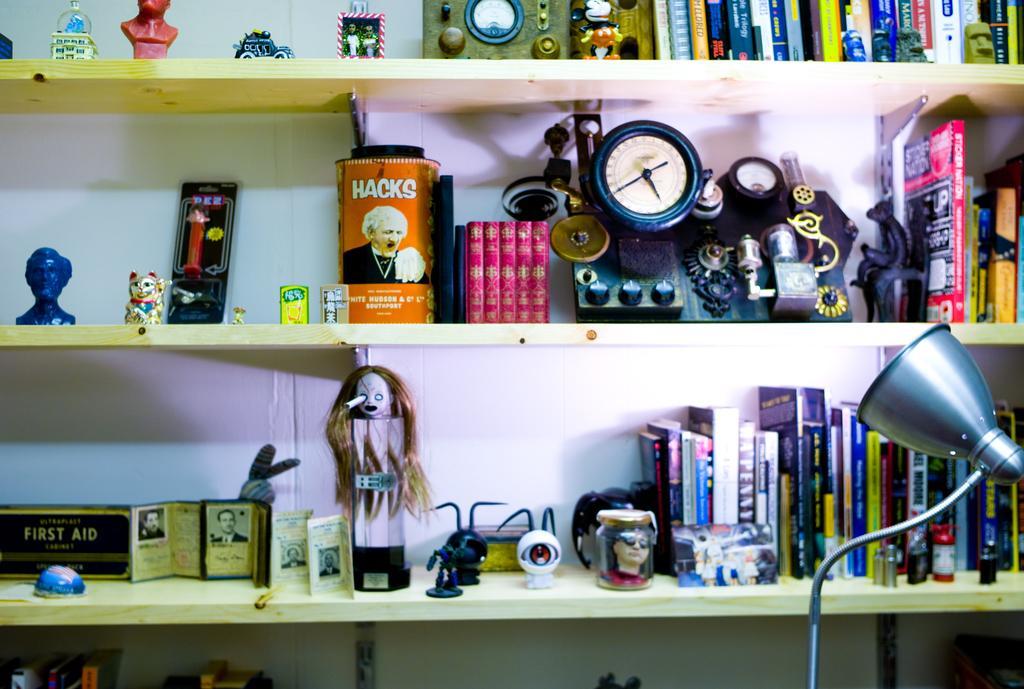Can you describe this image briefly? In this image in the front there is a light lamp on the right side. In the background there is a shelf and in the shelf there are objects like dolls, books, blocks and toys. 